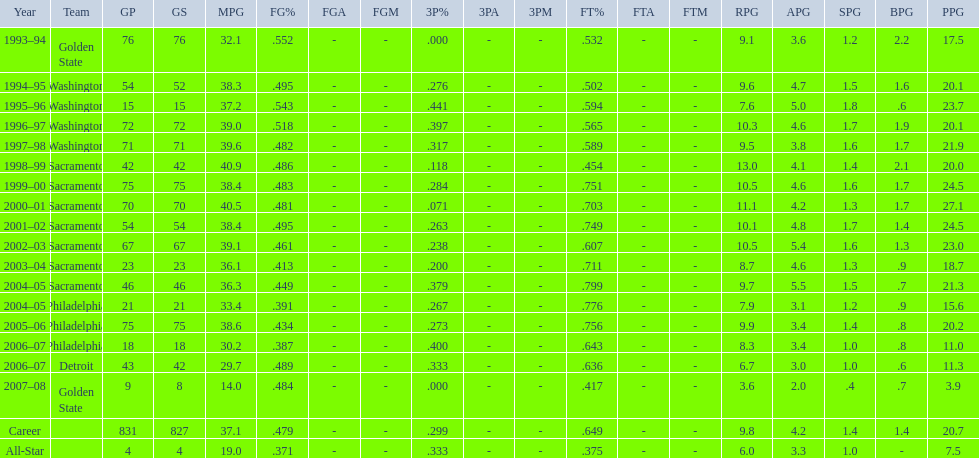How many seasons did webber average over 20 points per game (ppg)? 11. 